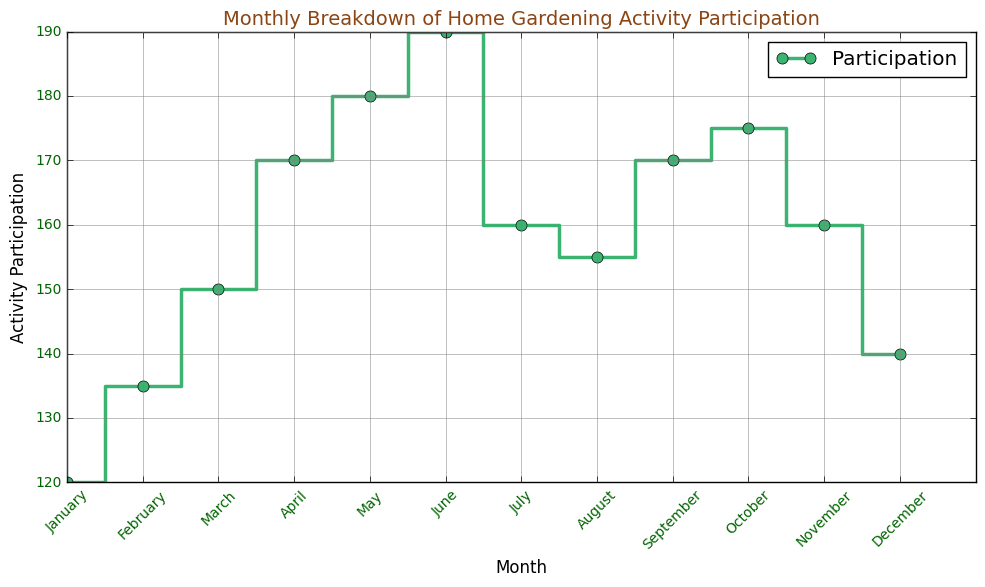Which month had the highest participation in home gardening activities? To find the month with the highest participation, look for the peak in the step plot. May and June both have participation values of 190, but since June continues at 190 while May is just ending, June is the highest.
Answer: June How much did activity participation increase from February to March? Calculate the participation increase by subtracting February's value from March's value: 150 - 135 = 15.
Answer: 15 During which months did the participation decrease compared to the previous month? Look for the descending steps in the plot. Participation decreases from June to July (190 to 160), August to September (160 to 155). Note: Only decreasing changes are observed between June to July.
Answer: July What is the average participation from January to December? Sum all monthly participation values and divide by the number of months. (120 + 135 + 150 + 170 + 180 + 190 + 160 + 155 + 170 + 175 + 160 + 140) / 12 = 1805 / 12 ≈ 150.42
Answer: 150.42 Which month showed the greatest one-month increase in participation? Identify the largest vertical step up between any two consecutive months. The largest increase is from April to May: 180 - 170 = 20.
Answer: May Is the participation in November higher or lower than in February? Compare the values directly: November's participation is 160 and February's is 135. Since 160 > 135, November is higher.
Answer: Higher What is the total participation for the summer months (June, July, August)? Add the participation values for June, July, and August: 190 + 160 + 155 = 505.
Answer: 505 By how much did the participation increase from January to December? Subtract January's value from December's value: 140 - 120 = 20.
Answer: 20 Which month had the lowest participation, and what was the value? Identify the lowest point on the step plot. The lowest participation is in January with a value of 120.
Answer: January, 120 Was participation more stable in the first half of the year (January to June) or the second half (July to December)? Calculate the range for both halves: 
First half: highest (June=190) - lowest (January=120) = 70.
Second half: highest (October=175) - lowest (December=140) = 35.
The second half has a smaller range, indicating more stability.
Answer: Second half 